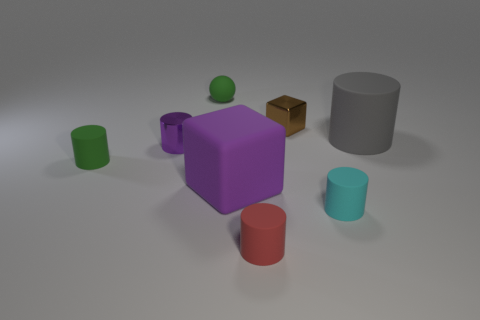Subtract all cyan cylinders. How many cylinders are left? 4 Add 1 big red shiny objects. How many objects exist? 9 Subtract all gray cylinders. How many cylinders are left? 4 Subtract 1 cylinders. How many cylinders are left? 4 Subtract all tiny purple rubber cylinders. Subtract all spheres. How many objects are left? 7 Add 8 small metal cylinders. How many small metal cylinders are left? 9 Add 6 large blue metallic balls. How many large blue metallic balls exist? 6 Subtract 0 green cubes. How many objects are left? 8 Subtract all balls. How many objects are left? 7 Subtract all cyan cylinders. Subtract all green blocks. How many cylinders are left? 4 